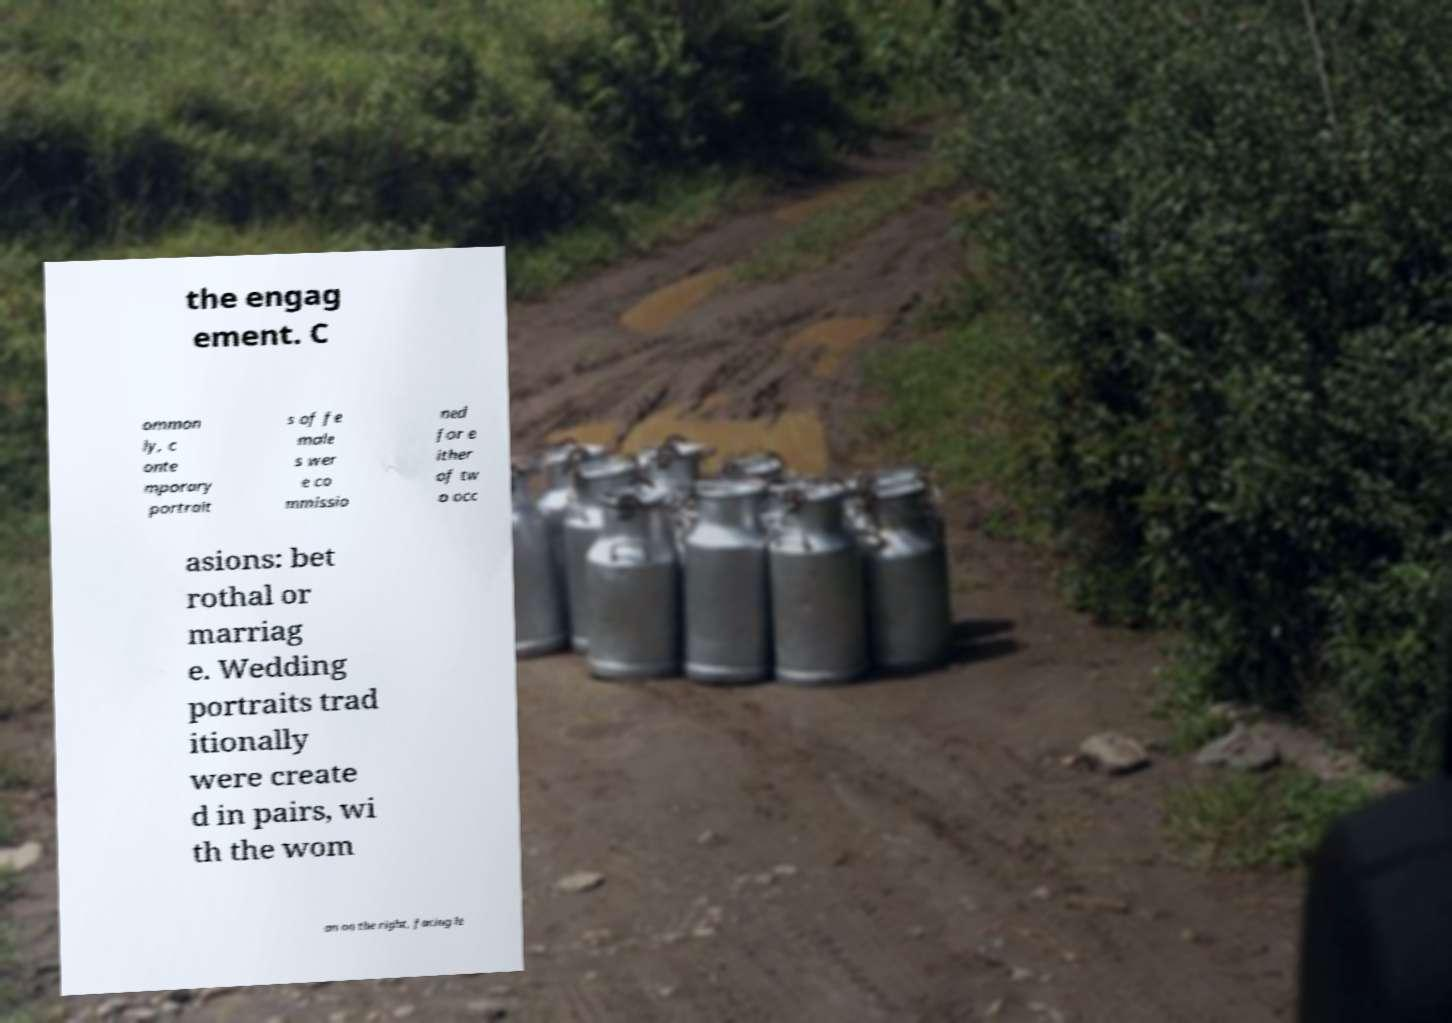Can you accurately transcribe the text from the provided image for me? the engag ement. C ommon ly, c onte mporary portrait s of fe male s wer e co mmissio ned for e ither of tw o occ asions: bet rothal or marriag e. Wedding portraits trad itionally were create d in pairs, wi th the wom an on the right, facing le 